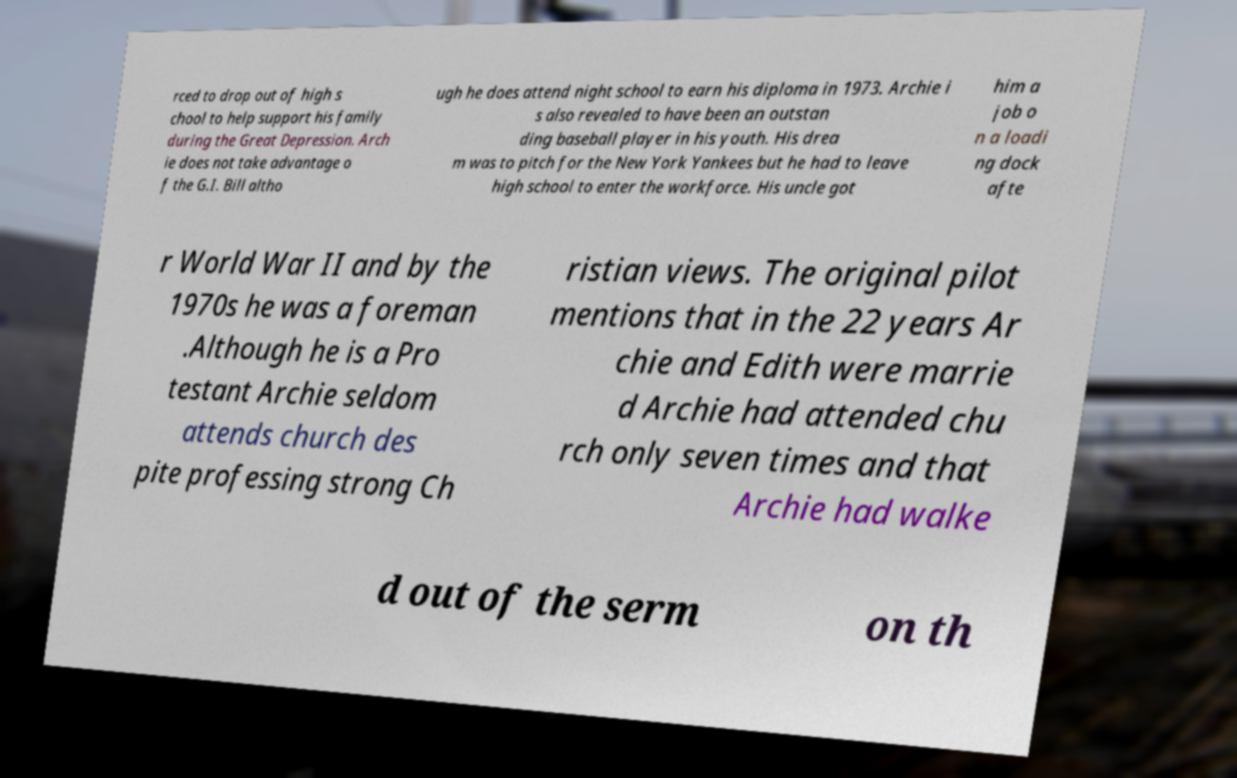For documentation purposes, I need the text within this image transcribed. Could you provide that? rced to drop out of high s chool to help support his family during the Great Depression. Arch ie does not take advantage o f the G.I. Bill altho ugh he does attend night school to earn his diploma in 1973. Archie i s also revealed to have been an outstan ding baseball player in his youth. His drea m was to pitch for the New York Yankees but he had to leave high school to enter the workforce. His uncle got him a job o n a loadi ng dock afte r World War II and by the 1970s he was a foreman .Although he is a Pro testant Archie seldom attends church des pite professing strong Ch ristian views. The original pilot mentions that in the 22 years Ar chie and Edith were marrie d Archie had attended chu rch only seven times and that Archie had walke d out of the serm on th 